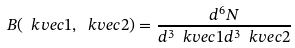<formula> <loc_0><loc_0><loc_500><loc_500>B ( \ k v e c { 1 } , \ k v e c { 2 } ) = \frac { d ^ { 6 } N } { d ^ { 3 } \ k v e c { 1 } d ^ { 3 } \ k v e c { 2 } }</formula> 